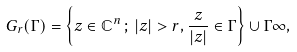Convert formula to latex. <formula><loc_0><loc_0><loc_500><loc_500>G _ { r } ( \Gamma ) = \left \{ z \in \mathbb { C } ^ { n } \, ; \, | z | > r , \frac { z } { | z | } \in \Gamma \right \} \cup \Gamma \infty ,</formula> 